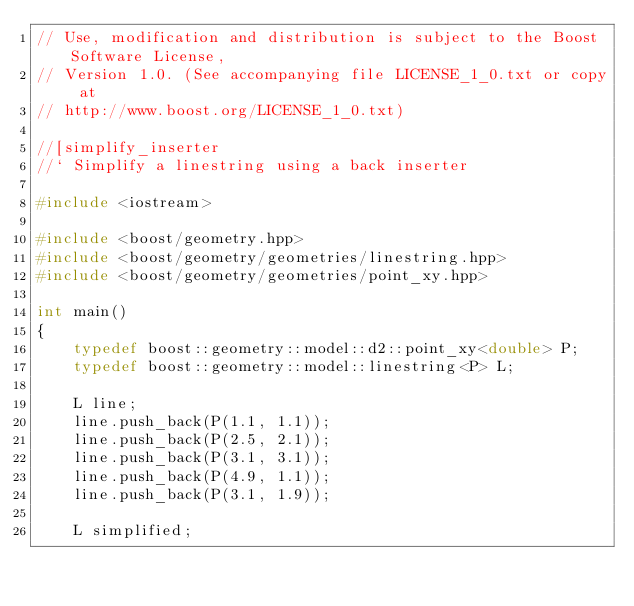<code> <loc_0><loc_0><loc_500><loc_500><_C++_>// Use, modification and distribution is subject to the Boost Software License,
// Version 1.0. (See accompanying file LICENSE_1_0.txt or copy at
// http://www.boost.org/LICENSE_1_0.txt)

//[simplify_inserter
//` Simplify a linestring using a back inserter

#include <iostream>

#include <boost/geometry.hpp>
#include <boost/geometry/geometries/linestring.hpp>
#include <boost/geometry/geometries/point_xy.hpp>

int main()
{
    typedef boost::geometry::model::d2::point_xy<double> P;
    typedef boost::geometry::model::linestring<P> L;

    L line;
    line.push_back(P(1.1, 1.1));
    line.push_back(P(2.5, 2.1));
    line.push_back(P(3.1, 3.1));
    line.push_back(P(4.9, 1.1));
    line.push_back(P(3.1, 1.9));

    L simplified;</code> 